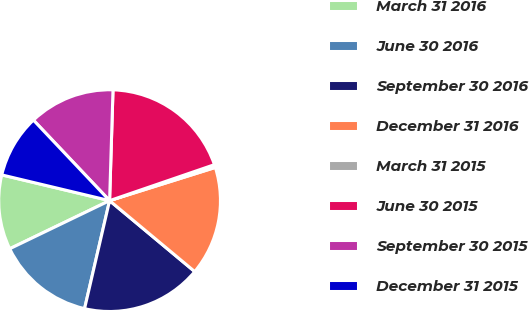Convert chart. <chart><loc_0><loc_0><loc_500><loc_500><pie_chart><fcel>March 31 2016<fcel>June 30 2016<fcel>September 30 2016<fcel>December 31 2016<fcel>March 31 2015<fcel>June 30 2015<fcel>September 30 2015<fcel>December 31 2015<nl><fcel>10.88%<fcel>14.23%<fcel>17.57%<fcel>15.9%<fcel>0.42%<fcel>19.25%<fcel>12.55%<fcel>9.21%<nl></chart> 